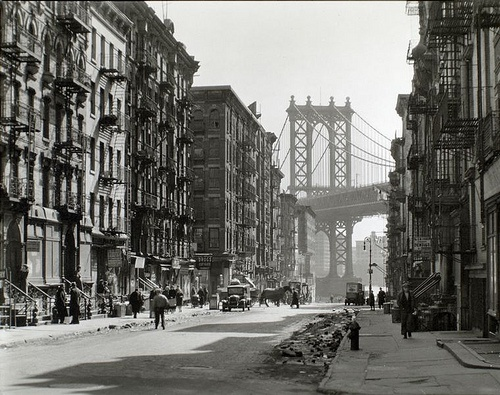Describe the objects in this image and their specific colors. I can see people in gray, black, darkgray, and lightgray tones, people in gray and black tones, truck in gray, black, darkgray, and lightgray tones, truck in gray and black tones, and people in gray, black, darkgray, and lightgray tones in this image. 